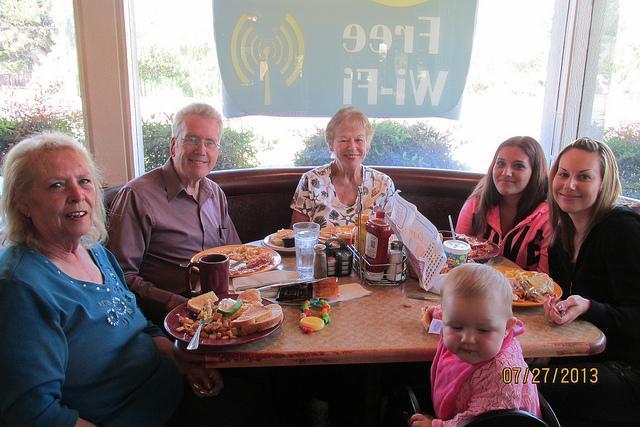How many people are there?
Give a very brief answer. 6. 